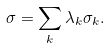Convert formula to latex. <formula><loc_0><loc_0><loc_500><loc_500>\sigma = \sum _ { k } \lambda _ { k } \sigma _ { k } .</formula> 